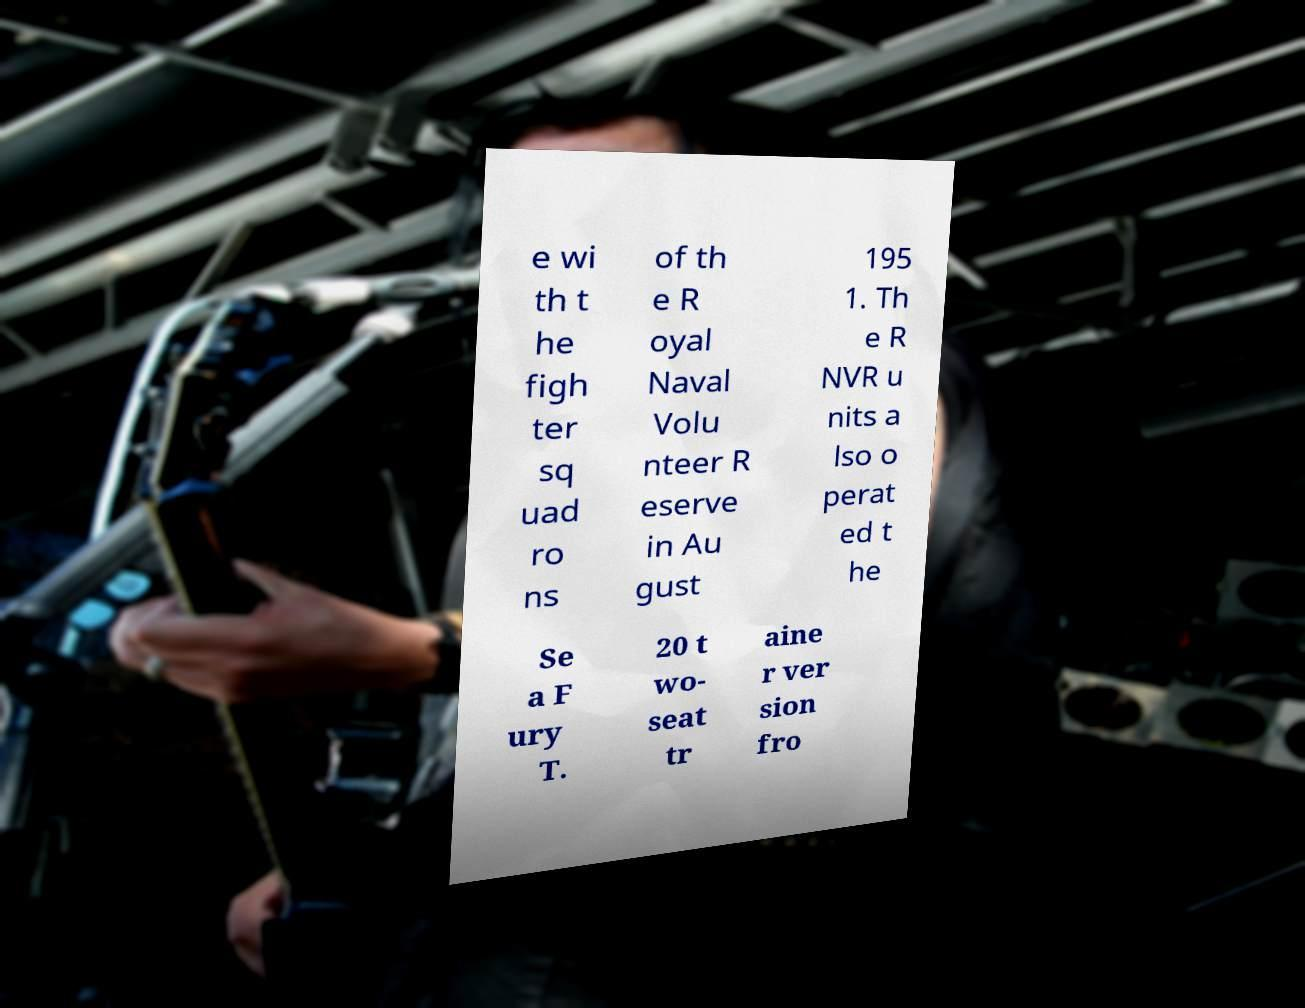Can you accurately transcribe the text from the provided image for me? e wi th t he figh ter sq uad ro ns of th e R oyal Naval Volu nteer R eserve in Au gust 195 1. Th e R NVR u nits a lso o perat ed t he Se a F ury T. 20 t wo- seat tr aine r ver sion fro 